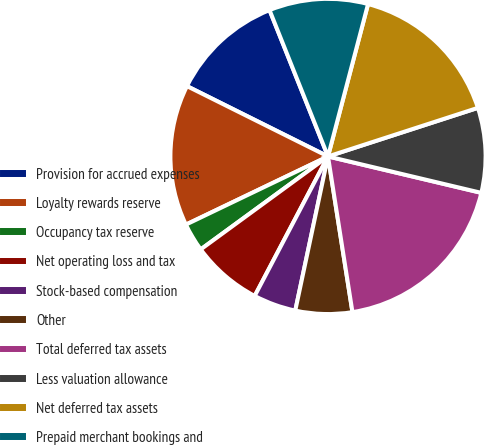<chart> <loc_0><loc_0><loc_500><loc_500><pie_chart><fcel>Provision for accrued expenses<fcel>Loyalty rewards reserve<fcel>Occupancy tax reserve<fcel>Net operating loss and tax<fcel>Stock-based compensation<fcel>Other<fcel>Total deferred tax assets<fcel>Less valuation allowance<fcel>Net deferred tax assets<fcel>Prepaid merchant bookings and<nl><fcel>11.59%<fcel>14.48%<fcel>2.92%<fcel>7.26%<fcel>4.37%<fcel>5.81%<fcel>18.81%<fcel>8.7%<fcel>15.92%<fcel>10.14%<nl></chart> 